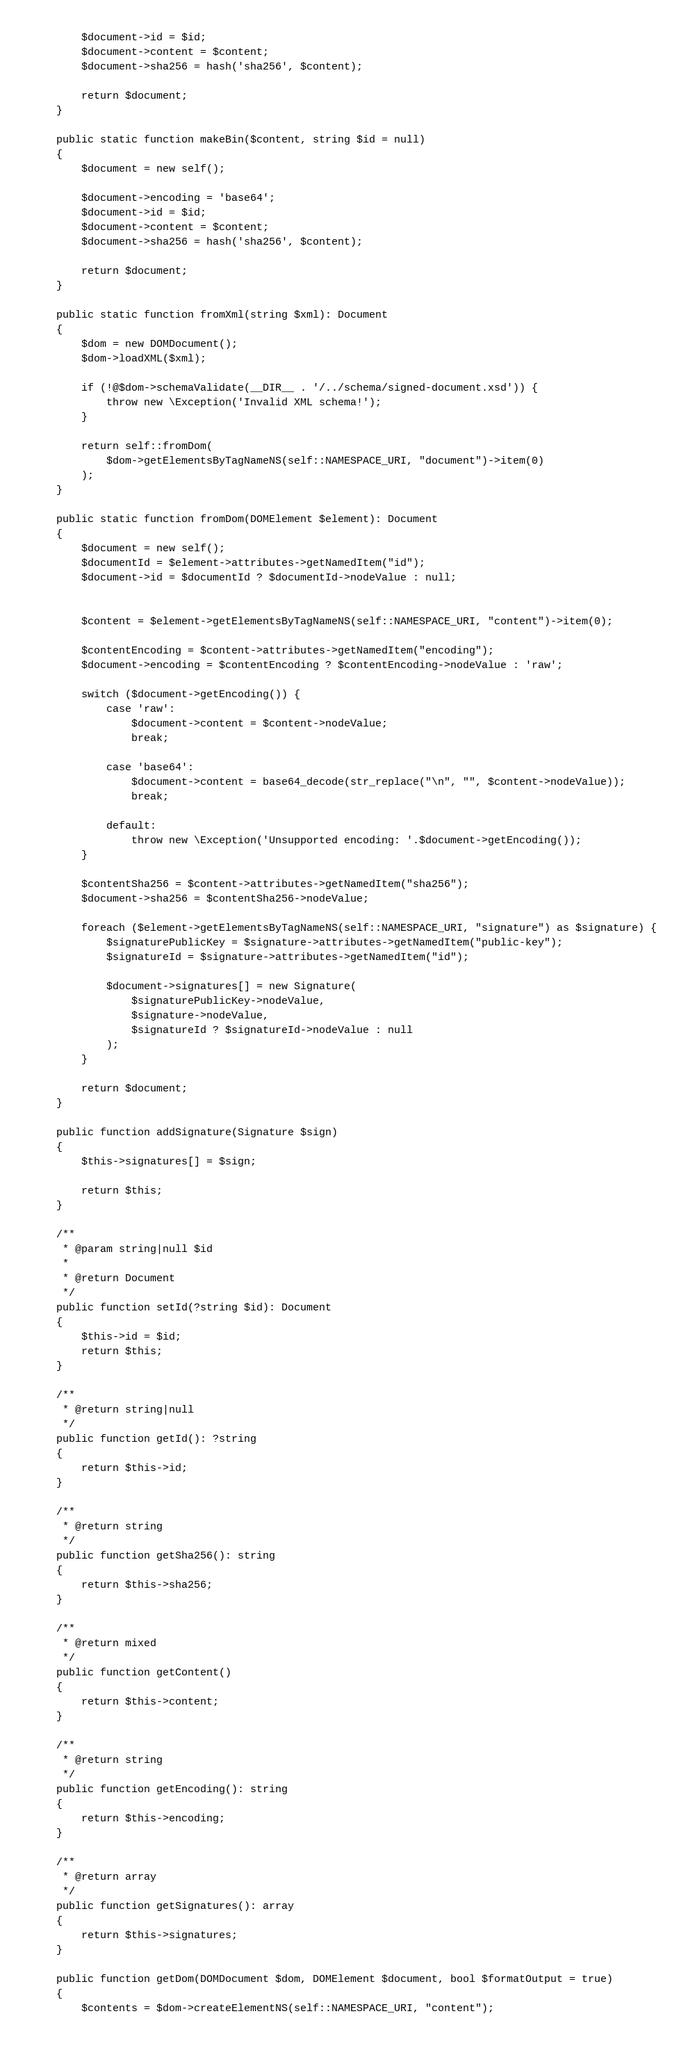Convert code to text. <code><loc_0><loc_0><loc_500><loc_500><_PHP_>        $document->id = $id;
        $document->content = $content;
        $document->sha256 = hash('sha256', $content);

        return $document;
    }

    public static function makeBin($content, string $id = null)
    {
        $document = new self();

        $document->encoding = 'base64';
        $document->id = $id;
        $document->content = $content;
        $document->sha256 = hash('sha256', $content);

        return $document;
    }

    public static function fromXml(string $xml): Document
    {
        $dom = new DOMDocument();
        $dom->loadXML($xml);

        if (!@$dom->schemaValidate(__DIR__ . '/../schema/signed-document.xsd')) {
            throw new \Exception('Invalid XML schema!');
        }

        return self::fromDom(
            $dom->getElementsByTagNameNS(self::NAMESPACE_URI, "document")->item(0)
        );
    }

    public static function fromDom(DOMElement $element): Document
    {
        $document = new self();
        $documentId = $element->attributes->getNamedItem("id");
        $document->id = $documentId ? $documentId->nodeValue : null;


        $content = $element->getElementsByTagNameNS(self::NAMESPACE_URI, "content")->item(0);

        $contentEncoding = $content->attributes->getNamedItem("encoding");
        $document->encoding = $contentEncoding ? $contentEncoding->nodeValue : 'raw';

        switch ($document->getEncoding()) {
            case 'raw':
                $document->content = $content->nodeValue;
                break;

            case 'base64':
                $document->content = base64_decode(str_replace("\n", "", $content->nodeValue));
                break;

            default:
                throw new \Exception('Unsupported encoding: '.$document->getEncoding());
        }

        $contentSha256 = $content->attributes->getNamedItem("sha256");
        $document->sha256 = $contentSha256->nodeValue;

        foreach ($element->getElementsByTagNameNS(self::NAMESPACE_URI, "signature") as $signature) {
            $signaturePublicKey = $signature->attributes->getNamedItem("public-key");
            $signatureId = $signature->attributes->getNamedItem("id");

            $document->signatures[] = new Signature(
                $signaturePublicKey->nodeValue,
                $signature->nodeValue,
                $signatureId ? $signatureId->nodeValue : null
            );
        }

        return $document;
    }

    public function addSignature(Signature $sign)
    {
        $this->signatures[] = $sign;

        return $this;
    }

    /**
     * @param string|null $id
     *
     * @return Document
     */
    public function setId(?string $id): Document
    {
        $this->id = $id;
        return $this;
    }

    /**
     * @return string|null
     */
    public function getId(): ?string
    {
        return $this->id;
    }

    /**
     * @return string
     */
    public function getSha256(): string
    {
        return $this->sha256;
    }

    /**
     * @return mixed
     */
    public function getContent()
    {
        return $this->content;
    }

    /**
     * @return string
     */
    public function getEncoding(): string
    {
        return $this->encoding;
    }

    /**
     * @return array
     */
    public function getSignatures(): array
    {
        return $this->signatures;
    }

    public function getDom(DOMDocument $dom, DOMElement $document, bool $formatOutput = true)
    {
        $contents = $dom->createElementNS(self::NAMESPACE_URI, "content");</code> 